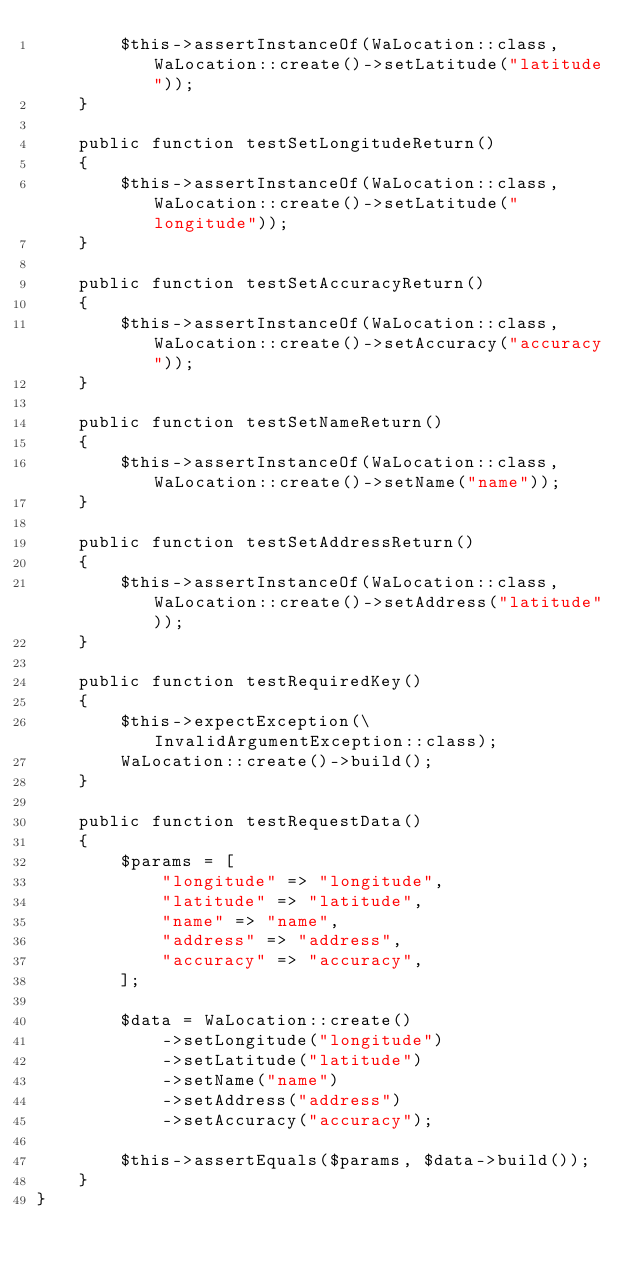Convert code to text. <code><loc_0><loc_0><loc_500><loc_500><_PHP_>        $this->assertInstanceOf(WaLocation::class, WaLocation::create()->setLatitude("latitude"));
    }

    public function testSetLongitudeReturn()
    {
        $this->assertInstanceOf(WaLocation::class, WaLocation::create()->setLatitude("longitude"));
    }

    public function testSetAccuracyReturn()
    {
        $this->assertInstanceOf(WaLocation::class, WaLocation::create()->setAccuracy("accuracy"));
    }

    public function testSetNameReturn()
    {
        $this->assertInstanceOf(WaLocation::class, WaLocation::create()->setName("name"));
    }

    public function testSetAddressReturn()
    {
        $this->assertInstanceOf(WaLocation::class, WaLocation::create()->setAddress("latitude"));
    }

    public function testRequiredKey()
    {
        $this->expectException(\InvalidArgumentException::class);
        WaLocation::create()->build();
    }

    public function testRequestData()
    {
        $params = [
            "longitude" => "longitude",
            "latitude" => "latitude",
            "name" => "name",
            "address" => "address",
            "accuracy" => "accuracy",
        ];

        $data = WaLocation::create()
            ->setLongitude("longitude")
            ->setLatitude("latitude")
            ->setName("name")
            ->setAddress("address")
            ->setAccuracy("accuracy");

        $this->assertEquals($params, $data->build());
    }
}</code> 